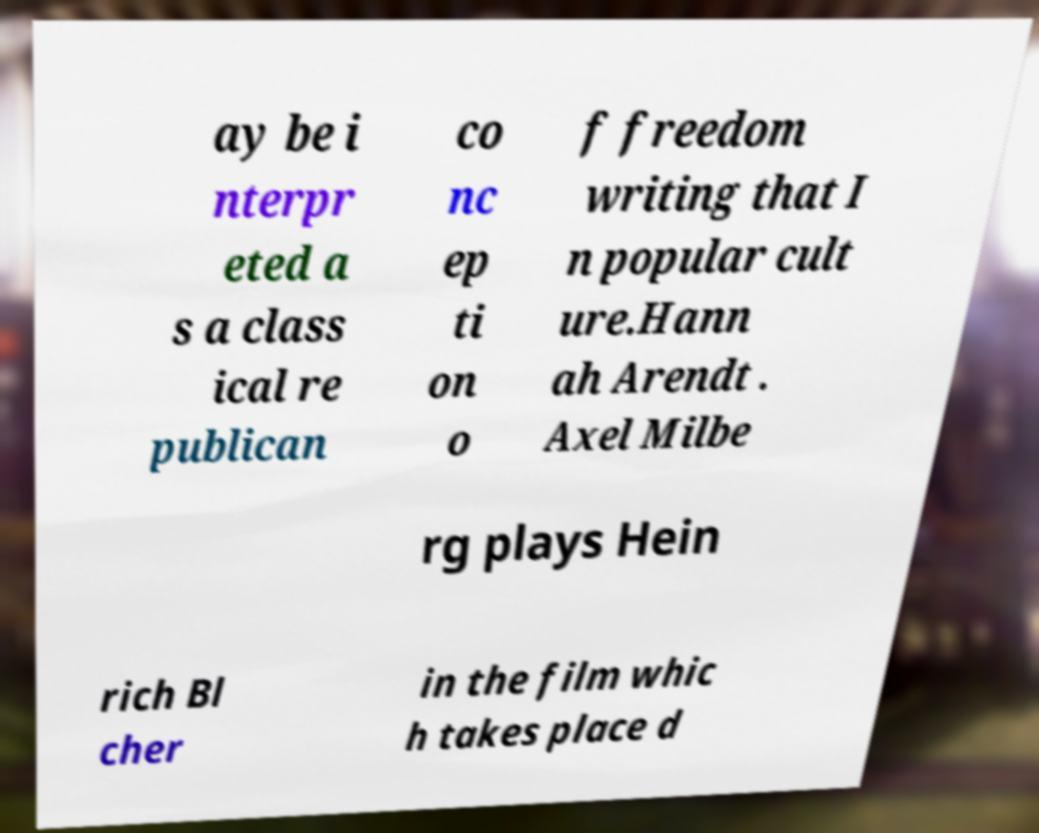Could you extract and type out the text from this image? ay be i nterpr eted a s a class ical re publican co nc ep ti on o f freedom writing that I n popular cult ure.Hann ah Arendt . Axel Milbe rg plays Hein rich Bl cher in the film whic h takes place d 